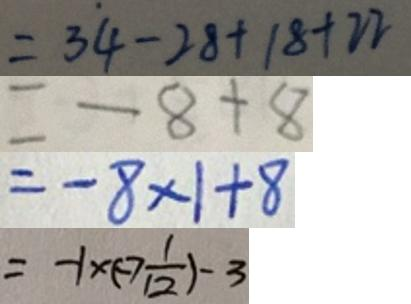Convert formula to latex. <formula><loc_0><loc_0><loc_500><loc_500>= 3 4 - 2 8 + 1 8 + 2 2 
 = - 8 + 8 
 = - 8 \times 1 + 8 
 = - 1 \times ( - 7 \frac { 1 } { 1 2 } ) - 3</formula> 